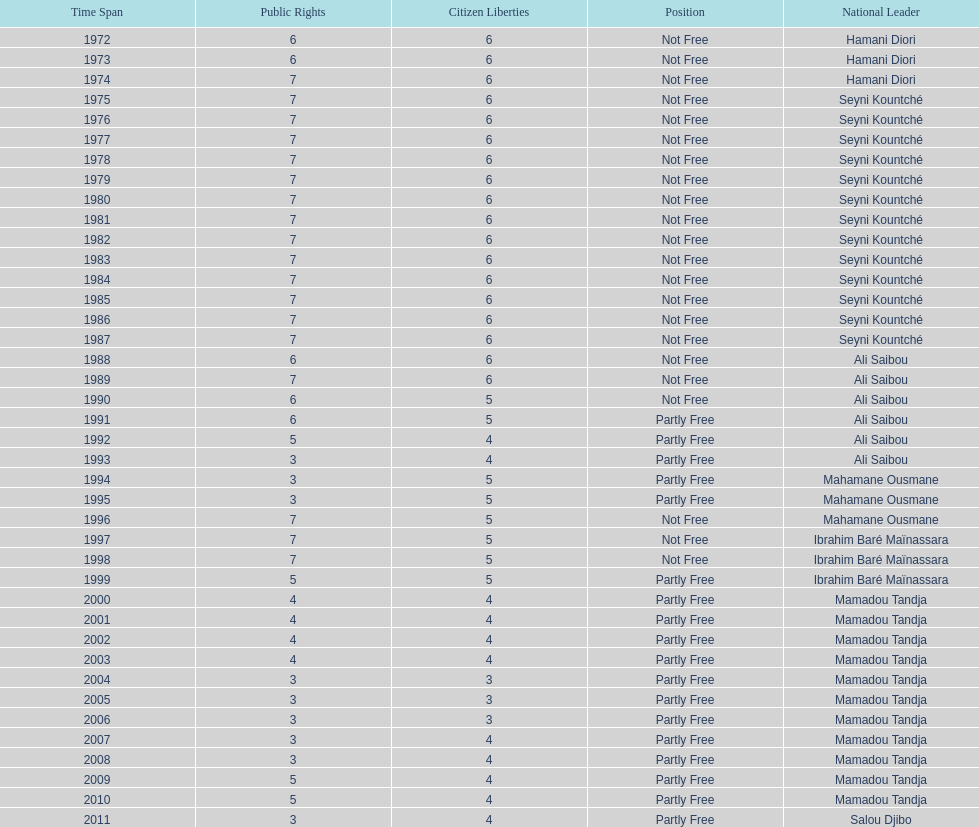Who was president before mamadou tandja? Ibrahim Baré Maïnassara. 